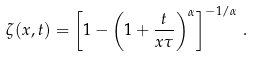Convert formula to latex. <formula><loc_0><loc_0><loc_500><loc_500>\zeta ( x , t ) = \left [ 1 - \left ( 1 + \frac { t } { x \tau } \right ) ^ { \alpha } \right ] ^ { - 1 / \alpha } \, .</formula> 